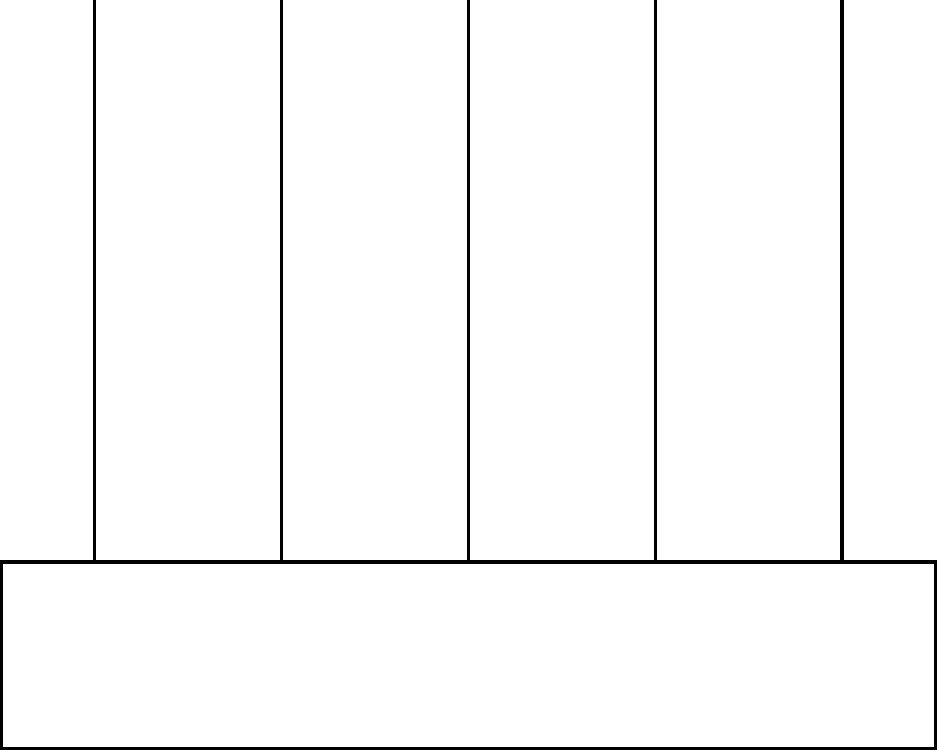In the context of translating ancient Islamic texts on heat transfer, consider a heat sink with multiple fins as shown in the diagram. How would you describe the temperature distribution along the length of a single fin, from its base to its tip, assuming steady-state conditions? To understand the temperature distribution along a fin, let's consider the heat transfer principles that would have been known in ancient Islamic scientific texts:

1. Heat conduction: The primary mode of heat transfer within the fin is conduction. Heat flows from higher temperature regions to lower temperature regions.

2. Temperature gradient: As we move away from the base of the fin towards its tip, the temperature gradually decreases.

3. Heat dissipation: The fin loses heat to the surrounding air through convection along its length.

4. Steady-state condition: The rate of heat entering the fin at its base is equal to the rate of heat dissipated to the surrounding air.

5. Fin efficiency: The effectiveness of the fin decreases as we move towards its tip, as less heat reaches the furthest points.

Given these principles, we can describe the temperature distribution as follows:

a) The temperature is highest at the base of the fin, where it connects to the heat sink's base.

b) As we move along the length of the fin, the temperature decreases non-linearly.

c) The rate of temperature decrease is steeper near the base and becomes more gradual towards the tip.

d) The temperature profile can be approximated by an exponential decay function:

   $$T(x) = T_∞ + (T_b - T_∞) \frac{\cosh[m(L-x)]}{\cosh(mL)}$$

   Where:
   $T(x)$ is the temperature at distance $x$ from the base
   $T_∞$ is the ambient air temperature
   $T_b$ is the base temperature
   $L$ is the length of the fin
   $m$ is a parameter depending on the fin's material and geometry

e) The tip of the fin will be at a temperature closer to the ambient air temperature, but not exactly equal to it.

This non-linear temperature distribution ensures efficient heat dissipation while maintaining a compact design, a concept that would have been valuable in ancient engineering applications.
Answer: Non-linear decrease from base to tip, approximated by exponential decay. 